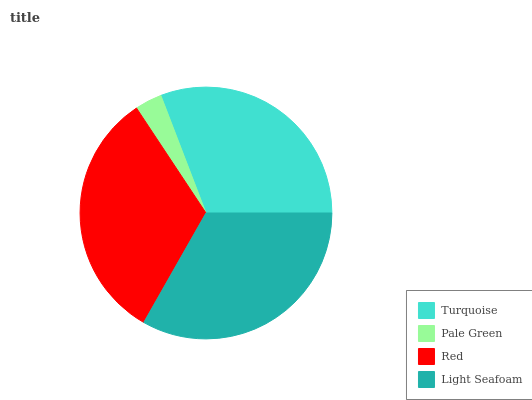Is Pale Green the minimum?
Answer yes or no. Yes. Is Light Seafoam the maximum?
Answer yes or no. Yes. Is Red the minimum?
Answer yes or no. No. Is Red the maximum?
Answer yes or no. No. Is Red greater than Pale Green?
Answer yes or no. Yes. Is Pale Green less than Red?
Answer yes or no. Yes. Is Pale Green greater than Red?
Answer yes or no. No. Is Red less than Pale Green?
Answer yes or no. No. Is Red the high median?
Answer yes or no. Yes. Is Turquoise the low median?
Answer yes or no. Yes. Is Light Seafoam the high median?
Answer yes or no. No. Is Red the low median?
Answer yes or no. No. 